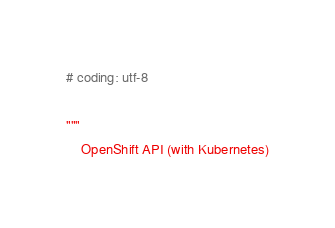Convert code to text. <code><loc_0><loc_0><loc_500><loc_500><_Python_># coding: utf-8

"""
    OpenShift API (with Kubernetes)
</code> 